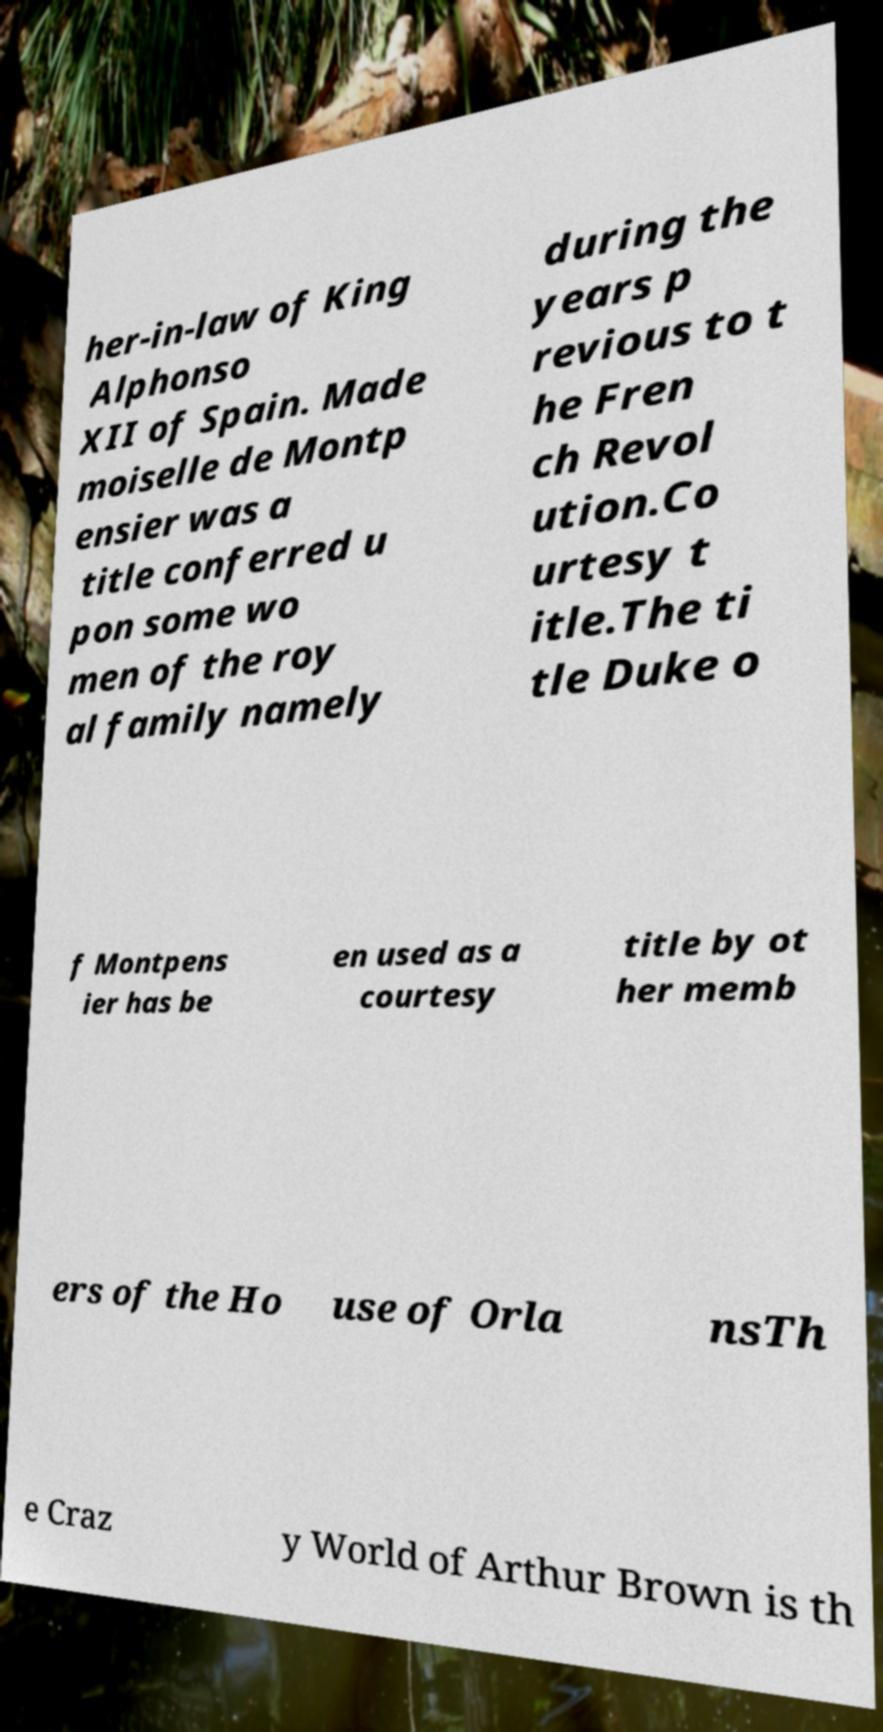I need the written content from this picture converted into text. Can you do that? her-in-law of King Alphonso XII of Spain. Made moiselle de Montp ensier was a title conferred u pon some wo men of the roy al family namely during the years p revious to t he Fren ch Revol ution.Co urtesy t itle.The ti tle Duke o f Montpens ier has be en used as a courtesy title by ot her memb ers of the Ho use of Orla nsTh e Craz y World of Arthur Brown is th 